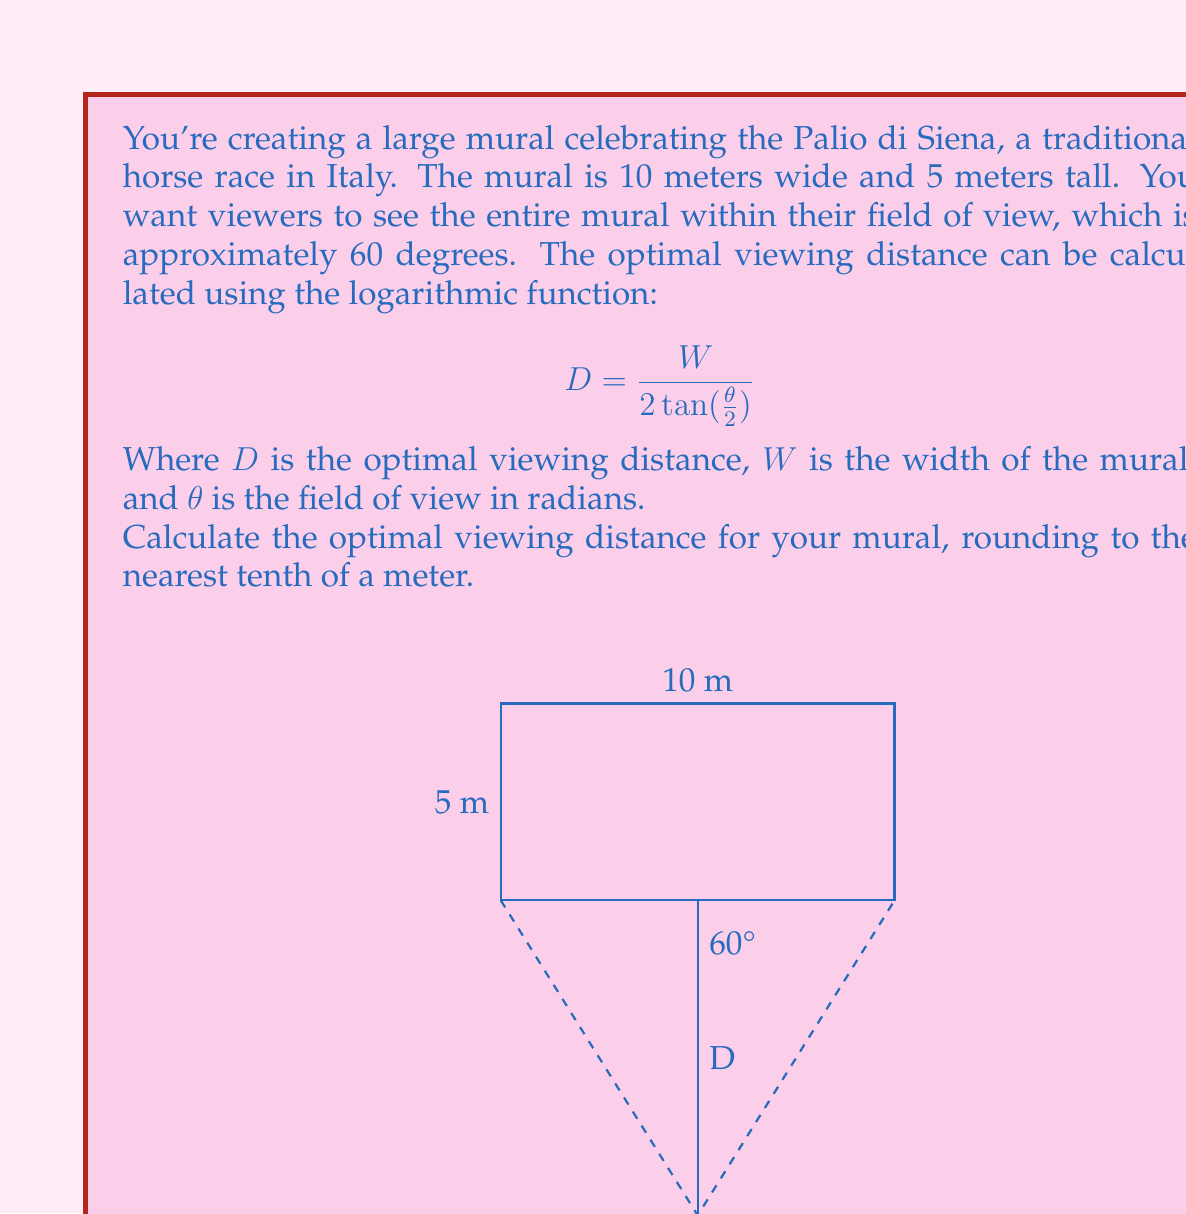Provide a solution to this math problem. Let's approach this step-by-step:

1) First, we need to convert the field of view from degrees to radians:
   $\theta = 60° \times \frac{\pi}{180°} = \frac{\pi}{3}$ radians

2) We know that $W = 10$ meters (the width of the mural).

3) Now we can plug these values into our formula:

   $$ D = \frac{W}{2 \tan(\frac{\theta}{2})} = \frac{10}{2 \tan(\frac{\pi}{6})} $$

4) Let's calculate $\tan(\frac{\pi}{6})$:
   $\tan(\frac{\pi}{6}) = \frac{1}{\sqrt{3}} \approx 0.5774$

5) Now we can complete our calculation:

   $$ D = \frac{10}{2 \times 0.5774} \approx 8.6602 $$

6) Rounding to the nearest tenth of a meter:
   $D \approx 8.7$ meters

Therefore, the optimal viewing distance for the mural is approximately 8.7 meters.
Answer: 8.7 meters 